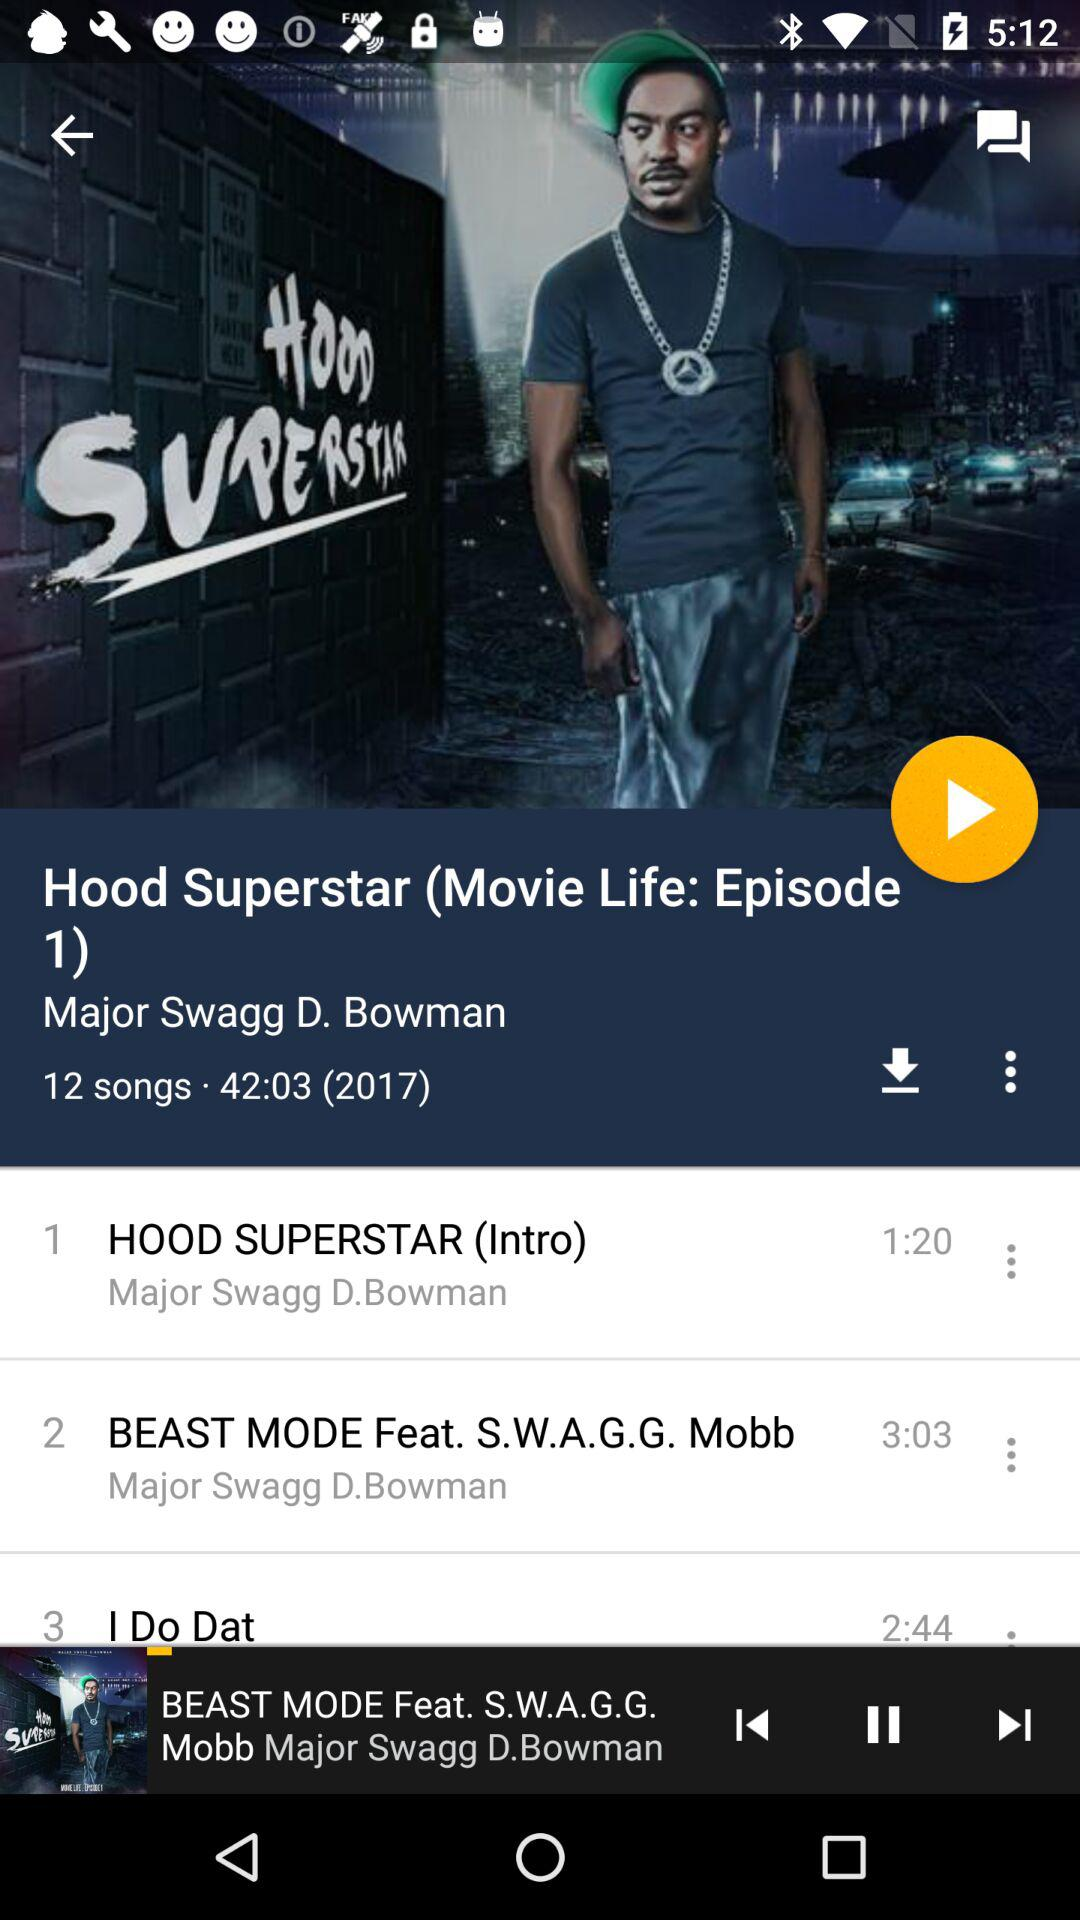What song is playing now?
Answer the question using a single word or phrase. The song is "BEAST MODE Feat. S.W.A.G.G." 